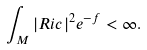<formula> <loc_0><loc_0><loc_500><loc_500>\int _ { M } | R i c | ^ { 2 } e ^ { - f } < \infty .</formula> 